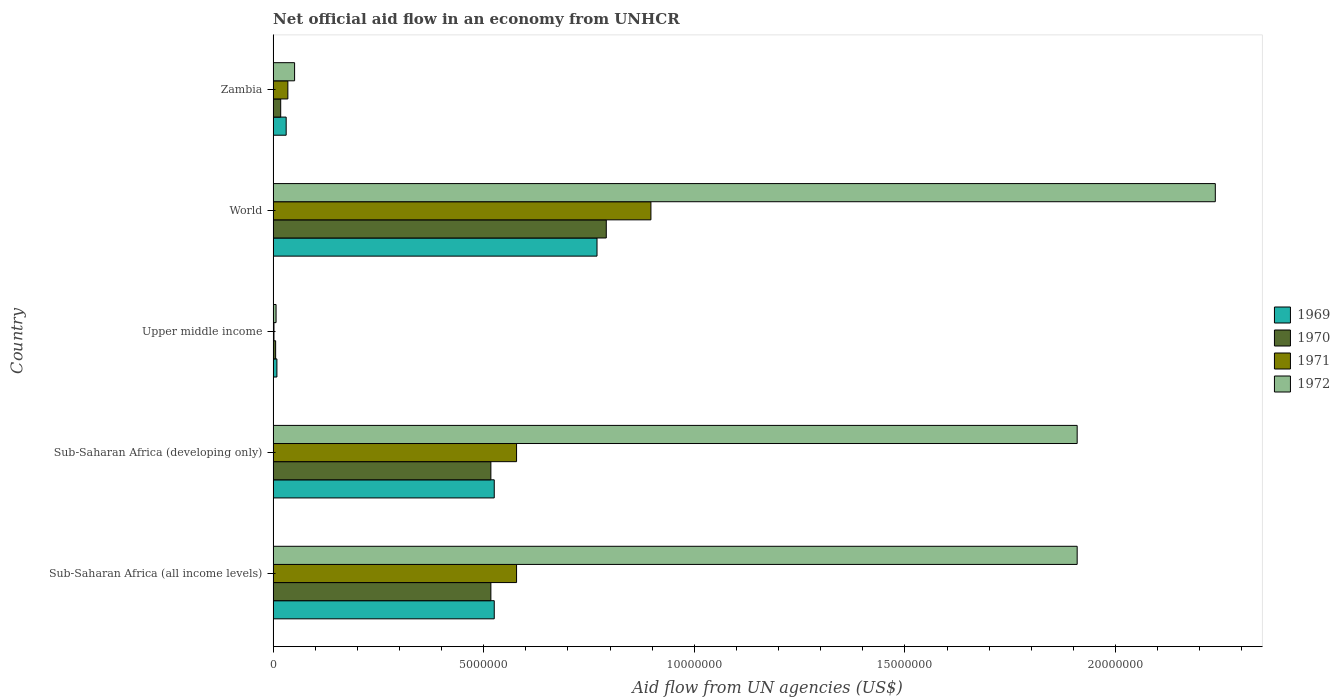Are the number of bars on each tick of the Y-axis equal?
Your response must be concise. Yes. How many bars are there on the 1st tick from the top?
Your response must be concise. 4. What is the label of the 5th group of bars from the top?
Your answer should be compact. Sub-Saharan Africa (all income levels). In how many cases, is the number of bars for a given country not equal to the number of legend labels?
Your answer should be very brief. 0. What is the net official aid flow in 1970 in Sub-Saharan Africa (developing only)?
Offer a very short reply. 5.17e+06. Across all countries, what is the maximum net official aid flow in 1971?
Keep it short and to the point. 8.97e+06. In which country was the net official aid flow in 1972 minimum?
Give a very brief answer. Upper middle income. What is the total net official aid flow in 1972 in the graph?
Your response must be concise. 6.11e+07. What is the difference between the net official aid flow in 1972 in Upper middle income and that in World?
Ensure brevity in your answer.  -2.23e+07. What is the difference between the net official aid flow in 1971 in Zambia and the net official aid flow in 1970 in World?
Provide a succinct answer. -7.56e+06. What is the average net official aid flow in 1969 per country?
Your answer should be compact. 3.72e+06. What is the difference between the net official aid flow in 1972 and net official aid flow in 1969 in Sub-Saharan Africa (developing only)?
Offer a terse response. 1.38e+07. What is the ratio of the net official aid flow in 1971 in Sub-Saharan Africa (all income levels) to that in Upper middle income?
Offer a terse response. 289. What is the difference between the highest and the second highest net official aid flow in 1969?
Provide a succinct answer. 2.44e+06. What is the difference between the highest and the lowest net official aid flow in 1971?
Your answer should be compact. 8.95e+06. In how many countries, is the net official aid flow in 1971 greater than the average net official aid flow in 1971 taken over all countries?
Offer a terse response. 3. Is it the case that in every country, the sum of the net official aid flow in 1969 and net official aid flow in 1972 is greater than the sum of net official aid flow in 1970 and net official aid flow in 1971?
Offer a terse response. No. What does the 1st bar from the bottom in World represents?
Provide a short and direct response. 1969. Is it the case that in every country, the sum of the net official aid flow in 1972 and net official aid flow in 1970 is greater than the net official aid flow in 1969?
Your answer should be compact. Yes. How many bars are there?
Provide a short and direct response. 20. Are all the bars in the graph horizontal?
Provide a short and direct response. Yes. What is the difference between two consecutive major ticks on the X-axis?
Keep it short and to the point. 5.00e+06. Are the values on the major ticks of X-axis written in scientific E-notation?
Give a very brief answer. No. Does the graph contain any zero values?
Provide a succinct answer. No. Does the graph contain grids?
Give a very brief answer. No. What is the title of the graph?
Make the answer very short. Net official aid flow in an economy from UNHCR. What is the label or title of the X-axis?
Your answer should be very brief. Aid flow from UN agencies (US$). What is the label or title of the Y-axis?
Your answer should be very brief. Country. What is the Aid flow from UN agencies (US$) of 1969 in Sub-Saharan Africa (all income levels)?
Your answer should be very brief. 5.25e+06. What is the Aid flow from UN agencies (US$) of 1970 in Sub-Saharan Africa (all income levels)?
Provide a succinct answer. 5.17e+06. What is the Aid flow from UN agencies (US$) in 1971 in Sub-Saharan Africa (all income levels)?
Your response must be concise. 5.78e+06. What is the Aid flow from UN agencies (US$) in 1972 in Sub-Saharan Africa (all income levels)?
Keep it short and to the point. 1.91e+07. What is the Aid flow from UN agencies (US$) of 1969 in Sub-Saharan Africa (developing only)?
Your answer should be compact. 5.25e+06. What is the Aid flow from UN agencies (US$) in 1970 in Sub-Saharan Africa (developing only)?
Your answer should be very brief. 5.17e+06. What is the Aid flow from UN agencies (US$) of 1971 in Sub-Saharan Africa (developing only)?
Ensure brevity in your answer.  5.78e+06. What is the Aid flow from UN agencies (US$) in 1972 in Sub-Saharan Africa (developing only)?
Make the answer very short. 1.91e+07. What is the Aid flow from UN agencies (US$) in 1969 in Upper middle income?
Provide a short and direct response. 9.00e+04. What is the Aid flow from UN agencies (US$) in 1972 in Upper middle income?
Provide a short and direct response. 7.00e+04. What is the Aid flow from UN agencies (US$) in 1969 in World?
Your answer should be compact. 7.69e+06. What is the Aid flow from UN agencies (US$) of 1970 in World?
Ensure brevity in your answer.  7.91e+06. What is the Aid flow from UN agencies (US$) in 1971 in World?
Make the answer very short. 8.97e+06. What is the Aid flow from UN agencies (US$) in 1972 in World?
Your answer should be compact. 2.24e+07. What is the Aid flow from UN agencies (US$) in 1969 in Zambia?
Your response must be concise. 3.10e+05. What is the Aid flow from UN agencies (US$) in 1970 in Zambia?
Your answer should be compact. 1.80e+05. What is the Aid flow from UN agencies (US$) of 1971 in Zambia?
Ensure brevity in your answer.  3.50e+05. What is the Aid flow from UN agencies (US$) of 1972 in Zambia?
Your answer should be compact. 5.10e+05. Across all countries, what is the maximum Aid flow from UN agencies (US$) in 1969?
Provide a short and direct response. 7.69e+06. Across all countries, what is the maximum Aid flow from UN agencies (US$) in 1970?
Ensure brevity in your answer.  7.91e+06. Across all countries, what is the maximum Aid flow from UN agencies (US$) of 1971?
Offer a terse response. 8.97e+06. Across all countries, what is the maximum Aid flow from UN agencies (US$) in 1972?
Offer a very short reply. 2.24e+07. Across all countries, what is the minimum Aid flow from UN agencies (US$) in 1970?
Give a very brief answer. 6.00e+04. Across all countries, what is the minimum Aid flow from UN agencies (US$) of 1972?
Ensure brevity in your answer.  7.00e+04. What is the total Aid flow from UN agencies (US$) in 1969 in the graph?
Provide a short and direct response. 1.86e+07. What is the total Aid flow from UN agencies (US$) of 1970 in the graph?
Ensure brevity in your answer.  1.85e+07. What is the total Aid flow from UN agencies (US$) of 1971 in the graph?
Offer a very short reply. 2.09e+07. What is the total Aid flow from UN agencies (US$) in 1972 in the graph?
Provide a succinct answer. 6.11e+07. What is the difference between the Aid flow from UN agencies (US$) of 1969 in Sub-Saharan Africa (all income levels) and that in Sub-Saharan Africa (developing only)?
Make the answer very short. 0. What is the difference between the Aid flow from UN agencies (US$) of 1971 in Sub-Saharan Africa (all income levels) and that in Sub-Saharan Africa (developing only)?
Offer a very short reply. 0. What is the difference between the Aid flow from UN agencies (US$) of 1972 in Sub-Saharan Africa (all income levels) and that in Sub-Saharan Africa (developing only)?
Offer a terse response. 0. What is the difference between the Aid flow from UN agencies (US$) of 1969 in Sub-Saharan Africa (all income levels) and that in Upper middle income?
Give a very brief answer. 5.16e+06. What is the difference between the Aid flow from UN agencies (US$) in 1970 in Sub-Saharan Africa (all income levels) and that in Upper middle income?
Offer a terse response. 5.11e+06. What is the difference between the Aid flow from UN agencies (US$) of 1971 in Sub-Saharan Africa (all income levels) and that in Upper middle income?
Give a very brief answer. 5.76e+06. What is the difference between the Aid flow from UN agencies (US$) in 1972 in Sub-Saharan Africa (all income levels) and that in Upper middle income?
Your answer should be compact. 1.90e+07. What is the difference between the Aid flow from UN agencies (US$) of 1969 in Sub-Saharan Africa (all income levels) and that in World?
Provide a short and direct response. -2.44e+06. What is the difference between the Aid flow from UN agencies (US$) of 1970 in Sub-Saharan Africa (all income levels) and that in World?
Make the answer very short. -2.74e+06. What is the difference between the Aid flow from UN agencies (US$) of 1971 in Sub-Saharan Africa (all income levels) and that in World?
Give a very brief answer. -3.19e+06. What is the difference between the Aid flow from UN agencies (US$) of 1972 in Sub-Saharan Africa (all income levels) and that in World?
Provide a succinct answer. -3.28e+06. What is the difference between the Aid flow from UN agencies (US$) in 1969 in Sub-Saharan Africa (all income levels) and that in Zambia?
Provide a succinct answer. 4.94e+06. What is the difference between the Aid flow from UN agencies (US$) of 1970 in Sub-Saharan Africa (all income levels) and that in Zambia?
Offer a terse response. 4.99e+06. What is the difference between the Aid flow from UN agencies (US$) of 1971 in Sub-Saharan Africa (all income levels) and that in Zambia?
Keep it short and to the point. 5.43e+06. What is the difference between the Aid flow from UN agencies (US$) in 1972 in Sub-Saharan Africa (all income levels) and that in Zambia?
Make the answer very short. 1.86e+07. What is the difference between the Aid flow from UN agencies (US$) in 1969 in Sub-Saharan Africa (developing only) and that in Upper middle income?
Offer a very short reply. 5.16e+06. What is the difference between the Aid flow from UN agencies (US$) of 1970 in Sub-Saharan Africa (developing only) and that in Upper middle income?
Offer a very short reply. 5.11e+06. What is the difference between the Aid flow from UN agencies (US$) of 1971 in Sub-Saharan Africa (developing only) and that in Upper middle income?
Your answer should be compact. 5.76e+06. What is the difference between the Aid flow from UN agencies (US$) in 1972 in Sub-Saharan Africa (developing only) and that in Upper middle income?
Ensure brevity in your answer.  1.90e+07. What is the difference between the Aid flow from UN agencies (US$) of 1969 in Sub-Saharan Africa (developing only) and that in World?
Keep it short and to the point. -2.44e+06. What is the difference between the Aid flow from UN agencies (US$) of 1970 in Sub-Saharan Africa (developing only) and that in World?
Make the answer very short. -2.74e+06. What is the difference between the Aid flow from UN agencies (US$) in 1971 in Sub-Saharan Africa (developing only) and that in World?
Your response must be concise. -3.19e+06. What is the difference between the Aid flow from UN agencies (US$) in 1972 in Sub-Saharan Africa (developing only) and that in World?
Offer a very short reply. -3.28e+06. What is the difference between the Aid flow from UN agencies (US$) in 1969 in Sub-Saharan Africa (developing only) and that in Zambia?
Your response must be concise. 4.94e+06. What is the difference between the Aid flow from UN agencies (US$) of 1970 in Sub-Saharan Africa (developing only) and that in Zambia?
Keep it short and to the point. 4.99e+06. What is the difference between the Aid flow from UN agencies (US$) in 1971 in Sub-Saharan Africa (developing only) and that in Zambia?
Provide a short and direct response. 5.43e+06. What is the difference between the Aid flow from UN agencies (US$) in 1972 in Sub-Saharan Africa (developing only) and that in Zambia?
Your answer should be compact. 1.86e+07. What is the difference between the Aid flow from UN agencies (US$) in 1969 in Upper middle income and that in World?
Offer a terse response. -7.60e+06. What is the difference between the Aid flow from UN agencies (US$) in 1970 in Upper middle income and that in World?
Give a very brief answer. -7.85e+06. What is the difference between the Aid flow from UN agencies (US$) in 1971 in Upper middle income and that in World?
Keep it short and to the point. -8.95e+06. What is the difference between the Aid flow from UN agencies (US$) of 1972 in Upper middle income and that in World?
Give a very brief answer. -2.23e+07. What is the difference between the Aid flow from UN agencies (US$) of 1970 in Upper middle income and that in Zambia?
Offer a terse response. -1.20e+05. What is the difference between the Aid flow from UN agencies (US$) of 1971 in Upper middle income and that in Zambia?
Offer a very short reply. -3.30e+05. What is the difference between the Aid flow from UN agencies (US$) of 1972 in Upper middle income and that in Zambia?
Offer a terse response. -4.40e+05. What is the difference between the Aid flow from UN agencies (US$) in 1969 in World and that in Zambia?
Offer a very short reply. 7.38e+06. What is the difference between the Aid flow from UN agencies (US$) of 1970 in World and that in Zambia?
Offer a very short reply. 7.73e+06. What is the difference between the Aid flow from UN agencies (US$) of 1971 in World and that in Zambia?
Offer a terse response. 8.62e+06. What is the difference between the Aid flow from UN agencies (US$) in 1972 in World and that in Zambia?
Offer a terse response. 2.19e+07. What is the difference between the Aid flow from UN agencies (US$) of 1969 in Sub-Saharan Africa (all income levels) and the Aid flow from UN agencies (US$) of 1971 in Sub-Saharan Africa (developing only)?
Your answer should be compact. -5.30e+05. What is the difference between the Aid flow from UN agencies (US$) of 1969 in Sub-Saharan Africa (all income levels) and the Aid flow from UN agencies (US$) of 1972 in Sub-Saharan Africa (developing only)?
Ensure brevity in your answer.  -1.38e+07. What is the difference between the Aid flow from UN agencies (US$) in 1970 in Sub-Saharan Africa (all income levels) and the Aid flow from UN agencies (US$) in 1971 in Sub-Saharan Africa (developing only)?
Offer a very short reply. -6.10e+05. What is the difference between the Aid flow from UN agencies (US$) of 1970 in Sub-Saharan Africa (all income levels) and the Aid flow from UN agencies (US$) of 1972 in Sub-Saharan Africa (developing only)?
Your answer should be very brief. -1.39e+07. What is the difference between the Aid flow from UN agencies (US$) of 1971 in Sub-Saharan Africa (all income levels) and the Aid flow from UN agencies (US$) of 1972 in Sub-Saharan Africa (developing only)?
Your answer should be compact. -1.33e+07. What is the difference between the Aid flow from UN agencies (US$) of 1969 in Sub-Saharan Africa (all income levels) and the Aid flow from UN agencies (US$) of 1970 in Upper middle income?
Ensure brevity in your answer.  5.19e+06. What is the difference between the Aid flow from UN agencies (US$) in 1969 in Sub-Saharan Africa (all income levels) and the Aid flow from UN agencies (US$) in 1971 in Upper middle income?
Ensure brevity in your answer.  5.23e+06. What is the difference between the Aid flow from UN agencies (US$) in 1969 in Sub-Saharan Africa (all income levels) and the Aid flow from UN agencies (US$) in 1972 in Upper middle income?
Your answer should be compact. 5.18e+06. What is the difference between the Aid flow from UN agencies (US$) in 1970 in Sub-Saharan Africa (all income levels) and the Aid flow from UN agencies (US$) in 1971 in Upper middle income?
Offer a terse response. 5.15e+06. What is the difference between the Aid flow from UN agencies (US$) of 1970 in Sub-Saharan Africa (all income levels) and the Aid flow from UN agencies (US$) of 1972 in Upper middle income?
Your response must be concise. 5.10e+06. What is the difference between the Aid flow from UN agencies (US$) in 1971 in Sub-Saharan Africa (all income levels) and the Aid flow from UN agencies (US$) in 1972 in Upper middle income?
Provide a short and direct response. 5.71e+06. What is the difference between the Aid flow from UN agencies (US$) in 1969 in Sub-Saharan Africa (all income levels) and the Aid flow from UN agencies (US$) in 1970 in World?
Offer a terse response. -2.66e+06. What is the difference between the Aid flow from UN agencies (US$) in 1969 in Sub-Saharan Africa (all income levels) and the Aid flow from UN agencies (US$) in 1971 in World?
Your response must be concise. -3.72e+06. What is the difference between the Aid flow from UN agencies (US$) of 1969 in Sub-Saharan Africa (all income levels) and the Aid flow from UN agencies (US$) of 1972 in World?
Your response must be concise. -1.71e+07. What is the difference between the Aid flow from UN agencies (US$) of 1970 in Sub-Saharan Africa (all income levels) and the Aid flow from UN agencies (US$) of 1971 in World?
Offer a very short reply. -3.80e+06. What is the difference between the Aid flow from UN agencies (US$) of 1970 in Sub-Saharan Africa (all income levels) and the Aid flow from UN agencies (US$) of 1972 in World?
Your answer should be very brief. -1.72e+07. What is the difference between the Aid flow from UN agencies (US$) in 1971 in Sub-Saharan Africa (all income levels) and the Aid flow from UN agencies (US$) in 1972 in World?
Your answer should be very brief. -1.66e+07. What is the difference between the Aid flow from UN agencies (US$) of 1969 in Sub-Saharan Africa (all income levels) and the Aid flow from UN agencies (US$) of 1970 in Zambia?
Provide a succinct answer. 5.07e+06. What is the difference between the Aid flow from UN agencies (US$) of 1969 in Sub-Saharan Africa (all income levels) and the Aid flow from UN agencies (US$) of 1971 in Zambia?
Your response must be concise. 4.90e+06. What is the difference between the Aid flow from UN agencies (US$) in 1969 in Sub-Saharan Africa (all income levels) and the Aid flow from UN agencies (US$) in 1972 in Zambia?
Ensure brevity in your answer.  4.74e+06. What is the difference between the Aid flow from UN agencies (US$) in 1970 in Sub-Saharan Africa (all income levels) and the Aid flow from UN agencies (US$) in 1971 in Zambia?
Provide a short and direct response. 4.82e+06. What is the difference between the Aid flow from UN agencies (US$) in 1970 in Sub-Saharan Africa (all income levels) and the Aid flow from UN agencies (US$) in 1972 in Zambia?
Offer a very short reply. 4.66e+06. What is the difference between the Aid flow from UN agencies (US$) of 1971 in Sub-Saharan Africa (all income levels) and the Aid flow from UN agencies (US$) of 1972 in Zambia?
Your answer should be compact. 5.27e+06. What is the difference between the Aid flow from UN agencies (US$) of 1969 in Sub-Saharan Africa (developing only) and the Aid flow from UN agencies (US$) of 1970 in Upper middle income?
Your response must be concise. 5.19e+06. What is the difference between the Aid flow from UN agencies (US$) of 1969 in Sub-Saharan Africa (developing only) and the Aid flow from UN agencies (US$) of 1971 in Upper middle income?
Offer a terse response. 5.23e+06. What is the difference between the Aid flow from UN agencies (US$) in 1969 in Sub-Saharan Africa (developing only) and the Aid flow from UN agencies (US$) in 1972 in Upper middle income?
Offer a very short reply. 5.18e+06. What is the difference between the Aid flow from UN agencies (US$) in 1970 in Sub-Saharan Africa (developing only) and the Aid flow from UN agencies (US$) in 1971 in Upper middle income?
Ensure brevity in your answer.  5.15e+06. What is the difference between the Aid flow from UN agencies (US$) of 1970 in Sub-Saharan Africa (developing only) and the Aid flow from UN agencies (US$) of 1972 in Upper middle income?
Your response must be concise. 5.10e+06. What is the difference between the Aid flow from UN agencies (US$) of 1971 in Sub-Saharan Africa (developing only) and the Aid flow from UN agencies (US$) of 1972 in Upper middle income?
Your answer should be very brief. 5.71e+06. What is the difference between the Aid flow from UN agencies (US$) of 1969 in Sub-Saharan Africa (developing only) and the Aid flow from UN agencies (US$) of 1970 in World?
Your response must be concise. -2.66e+06. What is the difference between the Aid flow from UN agencies (US$) in 1969 in Sub-Saharan Africa (developing only) and the Aid flow from UN agencies (US$) in 1971 in World?
Keep it short and to the point. -3.72e+06. What is the difference between the Aid flow from UN agencies (US$) of 1969 in Sub-Saharan Africa (developing only) and the Aid flow from UN agencies (US$) of 1972 in World?
Give a very brief answer. -1.71e+07. What is the difference between the Aid flow from UN agencies (US$) in 1970 in Sub-Saharan Africa (developing only) and the Aid flow from UN agencies (US$) in 1971 in World?
Your answer should be very brief. -3.80e+06. What is the difference between the Aid flow from UN agencies (US$) in 1970 in Sub-Saharan Africa (developing only) and the Aid flow from UN agencies (US$) in 1972 in World?
Offer a very short reply. -1.72e+07. What is the difference between the Aid flow from UN agencies (US$) in 1971 in Sub-Saharan Africa (developing only) and the Aid flow from UN agencies (US$) in 1972 in World?
Your answer should be compact. -1.66e+07. What is the difference between the Aid flow from UN agencies (US$) of 1969 in Sub-Saharan Africa (developing only) and the Aid flow from UN agencies (US$) of 1970 in Zambia?
Offer a terse response. 5.07e+06. What is the difference between the Aid flow from UN agencies (US$) of 1969 in Sub-Saharan Africa (developing only) and the Aid flow from UN agencies (US$) of 1971 in Zambia?
Offer a very short reply. 4.90e+06. What is the difference between the Aid flow from UN agencies (US$) of 1969 in Sub-Saharan Africa (developing only) and the Aid flow from UN agencies (US$) of 1972 in Zambia?
Your response must be concise. 4.74e+06. What is the difference between the Aid flow from UN agencies (US$) of 1970 in Sub-Saharan Africa (developing only) and the Aid flow from UN agencies (US$) of 1971 in Zambia?
Your answer should be very brief. 4.82e+06. What is the difference between the Aid flow from UN agencies (US$) of 1970 in Sub-Saharan Africa (developing only) and the Aid flow from UN agencies (US$) of 1972 in Zambia?
Give a very brief answer. 4.66e+06. What is the difference between the Aid flow from UN agencies (US$) in 1971 in Sub-Saharan Africa (developing only) and the Aid flow from UN agencies (US$) in 1972 in Zambia?
Your answer should be compact. 5.27e+06. What is the difference between the Aid flow from UN agencies (US$) of 1969 in Upper middle income and the Aid flow from UN agencies (US$) of 1970 in World?
Your answer should be very brief. -7.82e+06. What is the difference between the Aid flow from UN agencies (US$) in 1969 in Upper middle income and the Aid flow from UN agencies (US$) in 1971 in World?
Offer a terse response. -8.88e+06. What is the difference between the Aid flow from UN agencies (US$) of 1969 in Upper middle income and the Aid flow from UN agencies (US$) of 1972 in World?
Your answer should be compact. -2.23e+07. What is the difference between the Aid flow from UN agencies (US$) of 1970 in Upper middle income and the Aid flow from UN agencies (US$) of 1971 in World?
Offer a very short reply. -8.91e+06. What is the difference between the Aid flow from UN agencies (US$) of 1970 in Upper middle income and the Aid flow from UN agencies (US$) of 1972 in World?
Ensure brevity in your answer.  -2.23e+07. What is the difference between the Aid flow from UN agencies (US$) in 1971 in Upper middle income and the Aid flow from UN agencies (US$) in 1972 in World?
Keep it short and to the point. -2.24e+07. What is the difference between the Aid flow from UN agencies (US$) in 1969 in Upper middle income and the Aid flow from UN agencies (US$) in 1971 in Zambia?
Offer a terse response. -2.60e+05. What is the difference between the Aid flow from UN agencies (US$) in 1969 in Upper middle income and the Aid flow from UN agencies (US$) in 1972 in Zambia?
Ensure brevity in your answer.  -4.20e+05. What is the difference between the Aid flow from UN agencies (US$) of 1970 in Upper middle income and the Aid flow from UN agencies (US$) of 1972 in Zambia?
Provide a succinct answer. -4.50e+05. What is the difference between the Aid flow from UN agencies (US$) in 1971 in Upper middle income and the Aid flow from UN agencies (US$) in 1972 in Zambia?
Your answer should be very brief. -4.90e+05. What is the difference between the Aid flow from UN agencies (US$) of 1969 in World and the Aid flow from UN agencies (US$) of 1970 in Zambia?
Ensure brevity in your answer.  7.51e+06. What is the difference between the Aid flow from UN agencies (US$) of 1969 in World and the Aid flow from UN agencies (US$) of 1971 in Zambia?
Your response must be concise. 7.34e+06. What is the difference between the Aid flow from UN agencies (US$) in 1969 in World and the Aid flow from UN agencies (US$) in 1972 in Zambia?
Your answer should be compact. 7.18e+06. What is the difference between the Aid flow from UN agencies (US$) of 1970 in World and the Aid flow from UN agencies (US$) of 1971 in Zambia?
Your answer should be compact. 7.56e+06. What is the difference between the Aid flow from UN agencies (US$) of 1970 in World and the Aid flow from UN agencies (US$) of 1972 in Zambia?
Provide a succinct answer. 7.40e+06. What is the difference between the Aid flow from UN agencies (US$) of 1971 in World and the Aid flow from UN agencies (US$) of 1972 in Zambia?
Provide a succinct answer. 8.46e+06. What is the average Aid flow from UN agencies (US$) of 1969 per country?
Give a very brief answer. 3.72e+06. What is the average Aid flow from UN agencies (US$) of 1970 per country?
Give a very brief answer. 3.70e+06. What is the average Aid flow from UN agencies (US$) of 1971 per country?
Offer a very short reply. 4.18e+06. What is the average Aid flow from UN agencies (US$) in 1972 per country?
Offer a terse response. 1.22e+07. What is the difference between the Aid flow from UN agencies (US$) in 1969 and Aid flow from UN agencies (US$) in 1970 in Sub-Saharan Africa (all income levels)?
Make the answer very short. 8.00e+04. What is the difference between the Aid flow from UN agencies (US$) in 1969 and Aid flow from UN agencies (US$) in 1971 in Sub-Saharan Africa (all income levels)?
Keep it short and to the point. -5.30e+05. What is the difference between the Aid flow from UN agencies (US$) in 1969 and Aid flow from UN agencies (US$) in 1972 in Sub-Saharan Africa (all income levels)?
Provide a succinct answer. -1.38e+07. What is the difference between the Aid flow from UN agencies (US$) in 1970 and Aid flow from UN agencies (US$) in 1971 in Sub-Saharan Africa (all income levels)?
Ensure brevity in your answer.  -6.10e+05. What is the difference between the Aid flow from UN agencies (US$) in 1970 and Aid flow from UN agencies (US$) in 1972 in Sub-Saharan Africa (all income levels)?
Offer a terse response. -1.39e+07. What is the difference between the Aid flow from UN agencies (US$) in 1971 and Aid flow from UN agencies (US$) in 1972 in Sub-Saharan Africa (all income levels)?
Keep it short and to the point. -1.33e+07. What is the difference between the Aid flow from UN agencies (US$) of 1969 and Aid flow from UN agencies (US$) of 1970 in Sub-Saharan Africa (developing only)?
Offer a terse response. 8.00e+04. What is the difference between the Aid flow from UN agencies (US$) in 1969 and Aid flow from UN agencies (US$) in 1971 in Sub-Saharan Africa (developing only)?
Keep it short and to the point. -5.30e+05. What is the difference between the Aid flow from UN agencies (US$) in 1969 and Aid flow from UN agencies (US$) in 1972 in Sub-Saharan Africa (developing only)?
Your answer should be compact. -1.38e+07. What is the difference between the Aid flow from UN agencies (US$) of 1970 and Aid flow from UN agencies (US$) of 1971 in Sub-Saharan Africa (developing only)?
Provide a short and direct response. -6.10e+05. What is the difference between the Aid flow from UN agencies (US$) of 1970 and Aid flow from UN agencies (US$) of 1972 in Sub-Saharan Africa (developing only)?
Your response must be concise. -1.39e+07. What is the difference between the Aid flow from UN agencies (US$) in 1971 and Aid flow from UN agencies (US$) in 1972 in Sub-Saharan Africa (developing only)?
Your answer should be very brief. -1.33e+07. What is the difference between the Aid flow from UN agencies (US$) of 1969 and Aid flow from UN agencies (US$) of 1971 in Upper middle income?
Your answer should be very brief. 7.00e+04. What is the difference between the Aid flow from UN agencies (US$) of 1970 and Aid flow from UN agencies (US$) of 1971 in Upper middle income?
Give a very brief answer. 4.00e+04. What is the difference between the Aid flow from UN agencies (US$) in 1970 and Aid flow from UN agencies (US$) in 1972 in Upper middle income?
Provide a short and direct response. -10000. What is the difference between the Aid flow from UN agencies (US$) of 1969 and Aid flow from UN agencies (US$) of 1970 in World?
Keep it short and to the point. -2.20e+05. What is the difference between the Aid flow from UN agencies (US$) in 1969 and Aid flow from UN agencies (US$) in 1971 in World?
Provide a short and direct response. -1.28e+06. What is the difference between the Aid flow from UN agencies (US$) of 1969 and Aid flow from UN agencies (US$) of 1972 in World?
Your response must be concise. -1.47e+07. What is the difference between the Aid flow from UN agencies (US$) of 1970 and Aid flow from UN agencies (US$) of 1971 in World?
Your answer should be compact. -1.06e+06. What is the difference between the Aid flow from UN agencies (US$) in 1970 and Aid flow from UN agencies (US$) in 1972 in World?
Your answer should be compact. -1.45e+07. What is the difference between the Aid flow from UN agencies (US$) of 1971 and Aid flow from UN agencies (US$) of 1972 in World?
Your answer should be very brief. -1.34e+07. What is the difference between the Aid flow from UN agencies (US$) of 1969 and Aid flow from UN agencies (US$) of 1970 in Zambia?
Ensure brevity in your answer.  1.30e+05. What is the difference between the Aid flow from UN agencies (US$) in 1970 and Aid flow from UN agencies (US$) in 1971 in Zambia?
Keep it short and to the point. -1.70e+05. What is the difference between the Aid flow from UN agencies (US$) in 1970 and Aid flow from UN agencies (US$) in 1972 in Zambia?
Ensure brevity in your answer.  -3.30e+05. What is the ratio of the Aid flow from UN agencies (US$) in 1970 in Sub-Saharan Africa (all income levels) to that in Sub-Saharan Africa (developing only)?
Ensure brevity in your answer.  1. What is the ratio of the Aid flow from UN agencies (US$) in 1971 in Sub-Saharan Africa (all income levels) to that in Sub-Saharan Africa (developing only)?
Ensure brevity in your answer.  1. What is the ratio of the Aid flow from UN agencies (US$) of 1969 in Sub-Saharan Africa (all income levels) to that in Upper middle income?
Provide a short and direct response. 58.33. What is the ratio of the Aid flow from UN agencies (US$) of 1970 in Sub-Saharan Africa (all income levels) to that in Upper middle income?
Your answer should be compact. 86.17. What is the ratio of the Aid flow from UN agencies (US$) in 1971 in Sub-Saharan Africa (all income levels) to that in Upper middle income?
Your answer should be very brief. 289. What is the ratio of the Aid flow from UN agencies (US$) of 1972 in Sub-Saharan Africa (all income levels) to that in Upper middle income?
Give a very brief answer. 272.71. What is the ratio of the Aid flow from UN agencies (US$) of 1969 in Sub-Saharan Africa (all income levels) to that in World?
Your answer should be very brief. 0.68. What is the ratio of the Aid flow from UN agencies (US$) in 1970 in Sub-Saharan Africa (all income levels) to that in World?
Offer a terse response. 0.65. What is the ratio of the Aid flow from UN agencies (US$) of 1971 in Sub-Saharan Africa (all income levels) to that in World?
Ensure brevity in your answer.  0.64. What is the ratio of the Aid flow from UN agencies (US$) in 1972 in Sub-Saharan Africa (all income levels) to that in World?
Offer a very short reply. 0.85. What is the ratio of the Aid flow from UN agencies (US$) of 1969 in Sub-Saharan Africa (all income levels) to that in Zambia?
Give a very brief answer. 16.94. What is the ratio of the Aid flow from UN agencies (US$) in 1970 in Sub-Saharan Africa (all income levels) to that in Zambia?
Your answer should be very brief. 28.72. What is the ratio of the Aid flow from UN agencies (US$) in 1971 in Sub-Saharan Africa (all income levels) to that in Zambia?
Your answer should be compact. 16.51. What is the ratio of the Aid flow from UN agencies (US$) of 1972 in Sub-Saharan Africa (all income levels) to that in Zambia?
Provide a succinct answer. 37.43. What is the ratio of the Aid flow from UN agencies (US$) of 1969 in Sub-Saharan Africa (developing only) to that in Upper middle income?
Make the answer very short. 58.33. What is the ratio of the Aid flow from UN agencies (US$) in 1970 in Sub-Saharan Africa (developing only) to that in Upper middle income?
Provide a succinct answer. 86.17. What is the ratio of the Aid flow from UN agencies (US$) of 1971 in Sub-Saharan Africa (developing only) to that in Upper middle income?
Offer a terse response. 289. What is the ratio of the Aid flow from UN agencies (US$) of 1972 in Sub-Saharan Africa (developing only) to that in Upper middle income?
Your answer should be very brief. 272.71. What is the ratio of the Aid flow from UN agencies (US$) in 1969 in Sub-Saharan Africa (developing only) to that in World?
Offer a terse response. 0.68. What is the ratio of the Aid flow from UN agencies (US$) in 1970 in Sub-Saharan Africa (developing only) to that in World?
Your response must be concise. 0.65. What is the ratio of the Aid flow from UN agencies (US$) of 1971 in Sub-Saharan Africa (developing only) to that in World?
Your answer should be compact. 0.64. What is the ratio of the Aid flow from UN agencies (US$) of 1972 in Sub-Saharan Africa (developing only) to that in World?
Provide a short and direct response. 0.85. What is the ratio of the Aid flow from UN agencies (US$) in 1969 in Sub-Saharan Africa (developing only) to that in Zambia?
Provide a succinct answer. 16.94. What is the ratio of the Aid flow from UN agencies (US$) in 1970 in Sub-Saharan Africa (developing only) to that in Zambia?
Offer a terse response. 28.72. What is the ratio of the Aid flow from UN agencies (US$) of 1971 in Sub-Saharan Africa (developing only) to that in Zambia?
Ensure brevity in your answer.  16.51. What is the ratio of the Aid flow from UN agencies (US$) of 1972 in Sub-Saharan Africa (developing only) to that in Zambia?
Offer a very short reply. 37.43. What is the ratio of the Aid flow from UN agencies (US$) of 1969 in Upper middle income to that in World?
Ensure brevity in your answer.  0.01. What is the ratio of the Aid flow from UN agencies (US$) of 1970 in Upper middle income to that in World?
Your answer should be compact. 0.01. What is the ratio of the Aid flow from UN agencies (US$) of 1971 in Upper middle income to that in World?
Your answer should be very brief. 0. What is the ratio of the Aid flow from UN agencies (US$) in 1972 in Upper middle income to that in World?
Keep it short and to the point. 0. What is the ratio of the Aid flow from UN agencies (US$) of 1969 in Upper middle income to that in Zambia?
Offer a terse response. 0.29. What is the ratio of the Aid flow from UN agencies (US$) in 1970 in Upper middle income to that in Zambia?
Make the answer very short. 0.33. What is the ratio of the Aid flow from UN agencies (US$) of 1971 in Upper middle income to that in Zambia?
Give a very brief answer. 0.06. What is the ratio of the Aid flow from UN agencies (US$) of 1972 in Upper middle income to that in Zambia?
Make the answer very short. 0.14. What is the ratio of the Aid flow from UN agencies (US$) of 1969 in World to that in Zambia?
Offer a terse response. 24.81. What is the ratio of the Aid flow from UN agencies (US$) of 1970 in World to that in Zambia?
Provide a succinct answer. 43.94. What is the ratio of the Aid flow from UN agencies (US$) of 1971 in World to that in Zambia?
Offer a very short reply. 25.63. What is the ratio of the Aid flow from UN agencies (US$) in 1972 in World to that in Zambia?
Your answer should be very brief. 43.86. What is the difference between the highest and the second highest Aid flow from UN agencies (US$) of 1969?
Keep it short and to the point. 2.44e+06. What is the difference between the highest and the second highest Aid flow from UN agencies (US$) of 1970?
Keep it short and to the point. 2.74e+06. What is the difference between the highest and the second highest Aid flow from UN agencies (US$) of 1971?
Make the answer very short. 3.19e+06. What is the difference between the highest and the second highest Aid flow from UN agencies (US$) of 1972?
Offer a terse response. 3.28e+06. What is the difference between the highest and the lowest Aid flow from UN agencies (US$) of 1969?
Ensure brevity in your answer.  7.60e+06. What is the difference between the highest and the lowest Aid flow from UN agencies (US$) in 1970?
Your response must be concise. 7.85e+06. What is the difference between the highest and the lowest Aid flow from UN agencies (US$) in 1971?
Your answer should be compact. 8.95e+06. What is the difference between the highest and the lowest Aid flow from UN agencies (US$) of 1972?
Keep it short and to the point. 2.23e+07. 